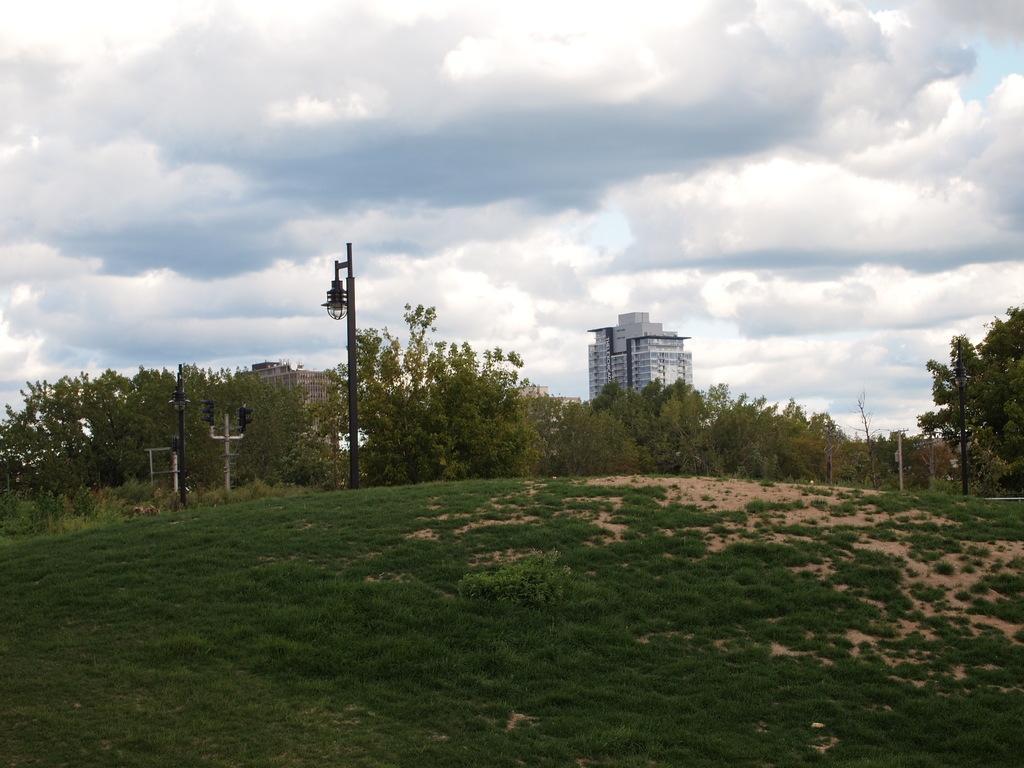Describe this image in one or two sentences. In this image we can see there are some trees, poles, lights, grass and buildings, in the background we can see the sky with clouds. 